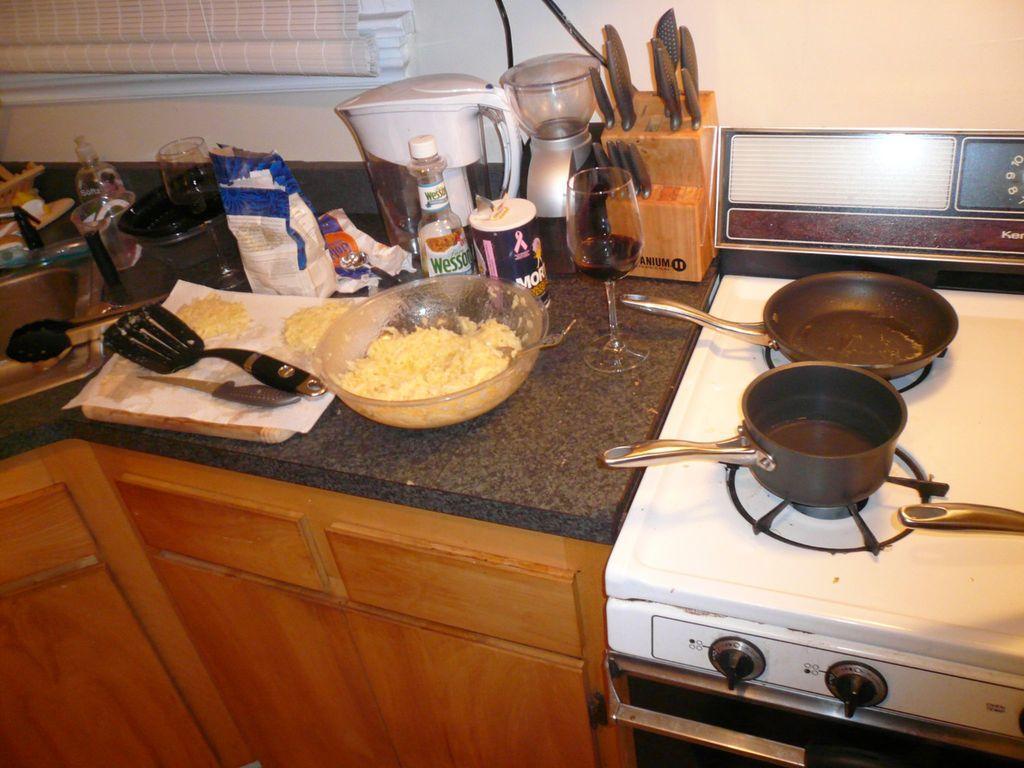Describe this image in one or two sentences. In this picture we can see a bowl, knives, glasses, bottles, machines and other things on the countertop, beside the countertop we can find bowls on the gas stove. 